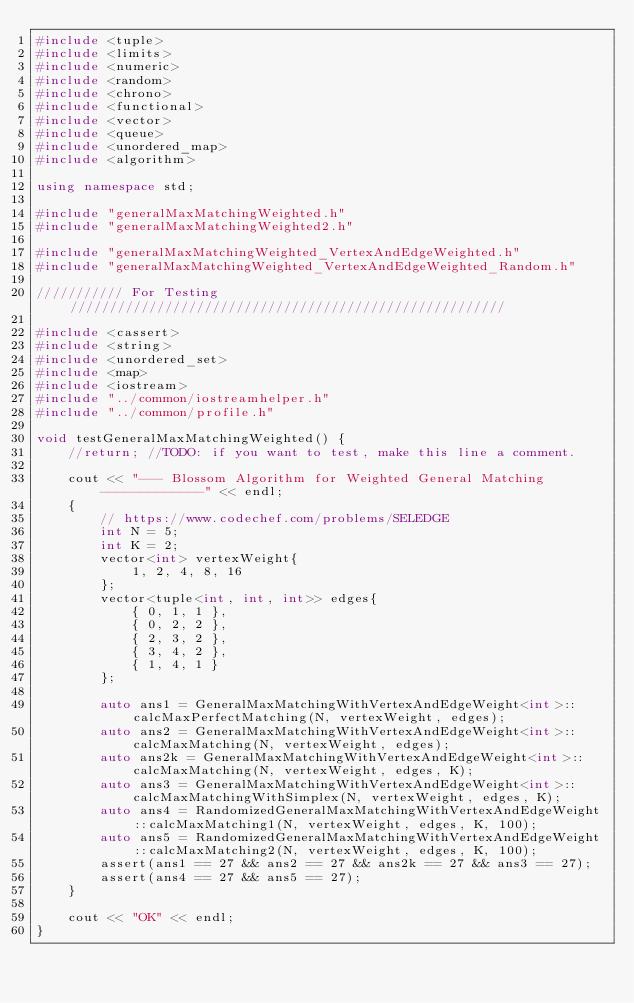Convert code to text. <code><loc_0><loc_0><loc_500><loc_500><_C++_>#include <tuple>
#include <limits>
#include <numeric>
#include <random>
#include <chrono>
#include <functional>
#include <vector>
#include <queue>
#include <unordered_map>
#include <algorithm>

using namespace std;

#include "generalMaxMatchingWeighted.h"
#include "generalMaxMatchingWeighted2.h"

#include "generalMaxMatchingWeighted_VertexAndEdgeWeighted.h"
#include "generalMaxMatchingWeighted_VertexAndEdgeWeighted_Random.h"

/////////// For Testing ///////////////////////////////////////////////////////

#include <cassert>
#include <string>
#include <unordered_set>
#include <map>
#include <iostream>
#include "../common/iostreamhelper.h"
#include "../common/profile.h"

void testGeneralMaxMatchingWeighted() {
    //return; //TODO: if you want to test, make this line a comment.

    cout << "--- Blossom Algorithm for Weighted General Matching -------------" << endl;
    {
        // https://www.codechef.com/problems/SELEDGE
        int N = 5;
        int K = 2;
        vector<int> vertexWeight{
            1, 2, 4, 8, 16
        };
        vector<tuple<int, int, int>> edges{
            { 0, 1, 1 },
            { 0, 2, 2 },
            { 2, 3, 2 },
            { 3, 4, 2 },
            { 1, 4, 1 }
        };

        auto ans1 = GeneralMaxMatchingWithVertexAndEdgeWeight<int>::calcMaxPerfectMatching(N, vertexWeight, edges);
        auto ans2 = GeneralMaxMatchingWithVertexAndEdgeWeight<int>::calcMaxMatching(N, vertexWeight, edges);
        auto ans2k = GeneralMaxMatchingWithVertexAndEdgeWeight<int>::calcMaxMatching(N, vertexWeight, edges, K);
        auto ans3 = GeneralMaxMatchingWithVertexAndEdgeWeight<int>::calcMaxMatchingWithSimplex(N, vertexWeight, edges, K);
        auto ans4 = RandomizedGeneralMaxMatchingWithVertexAndEdgeWeight::calcMaxMatching1(N, vertexWeight, edges, K, 100);
        auto ans5 = RandomizedGeneralMaxMatchingWithVertexAndEdgeWeight::calcMaxMatching2(N, vertexWeight, edges, K, 100);
        assert(ans1 == 27 && ans2 == 27 && ans2k == 27 && ans3 == 27);
        assert(ans4 == 27 && ans5 == 27);
    }

    cout << "OK" << endl;
}
</code> 